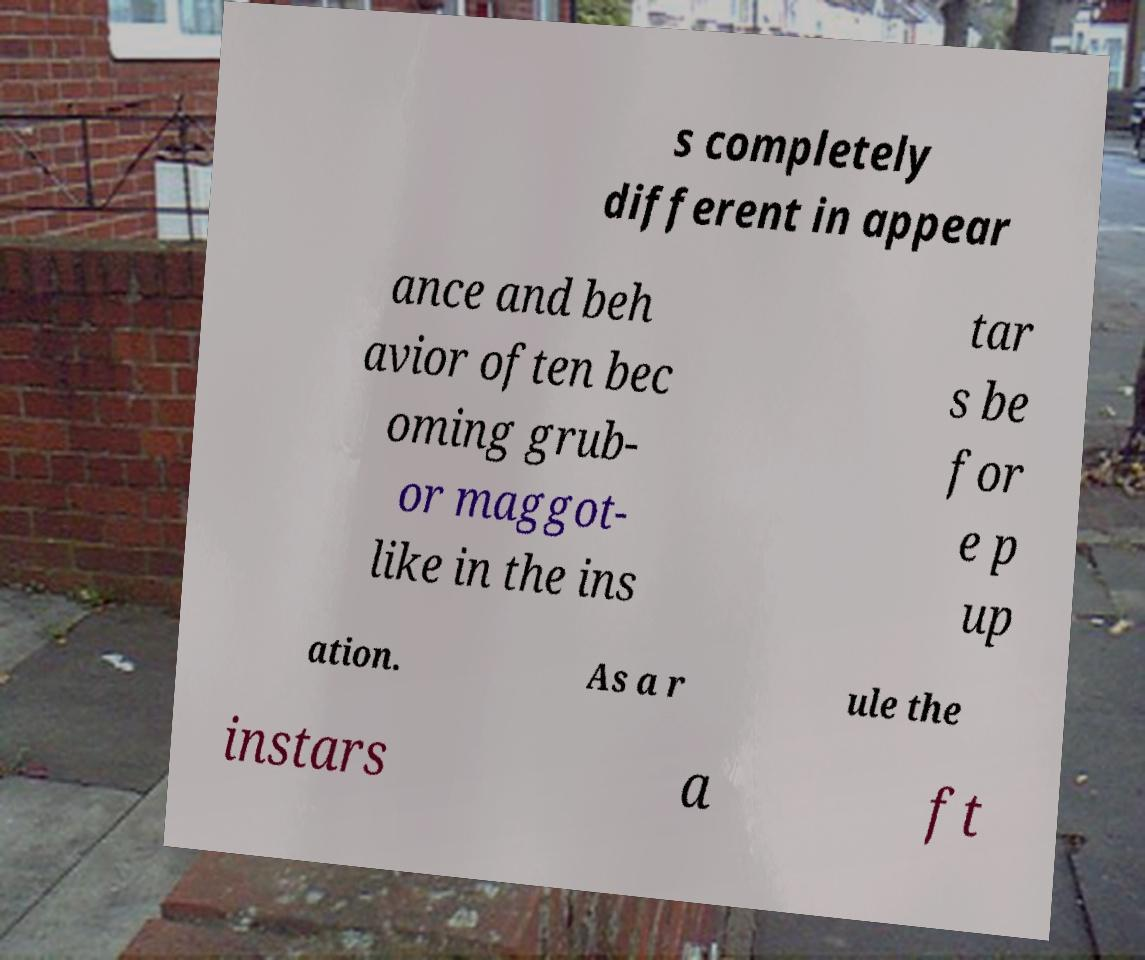There's text embedded in this image that I need extracted. Can you transcribe it verbatim? s completely different in appear ance and beh avior often bec oming grub- or maggot- like in the ins tar s be for e p up ation. As a r ule the instars a ft 